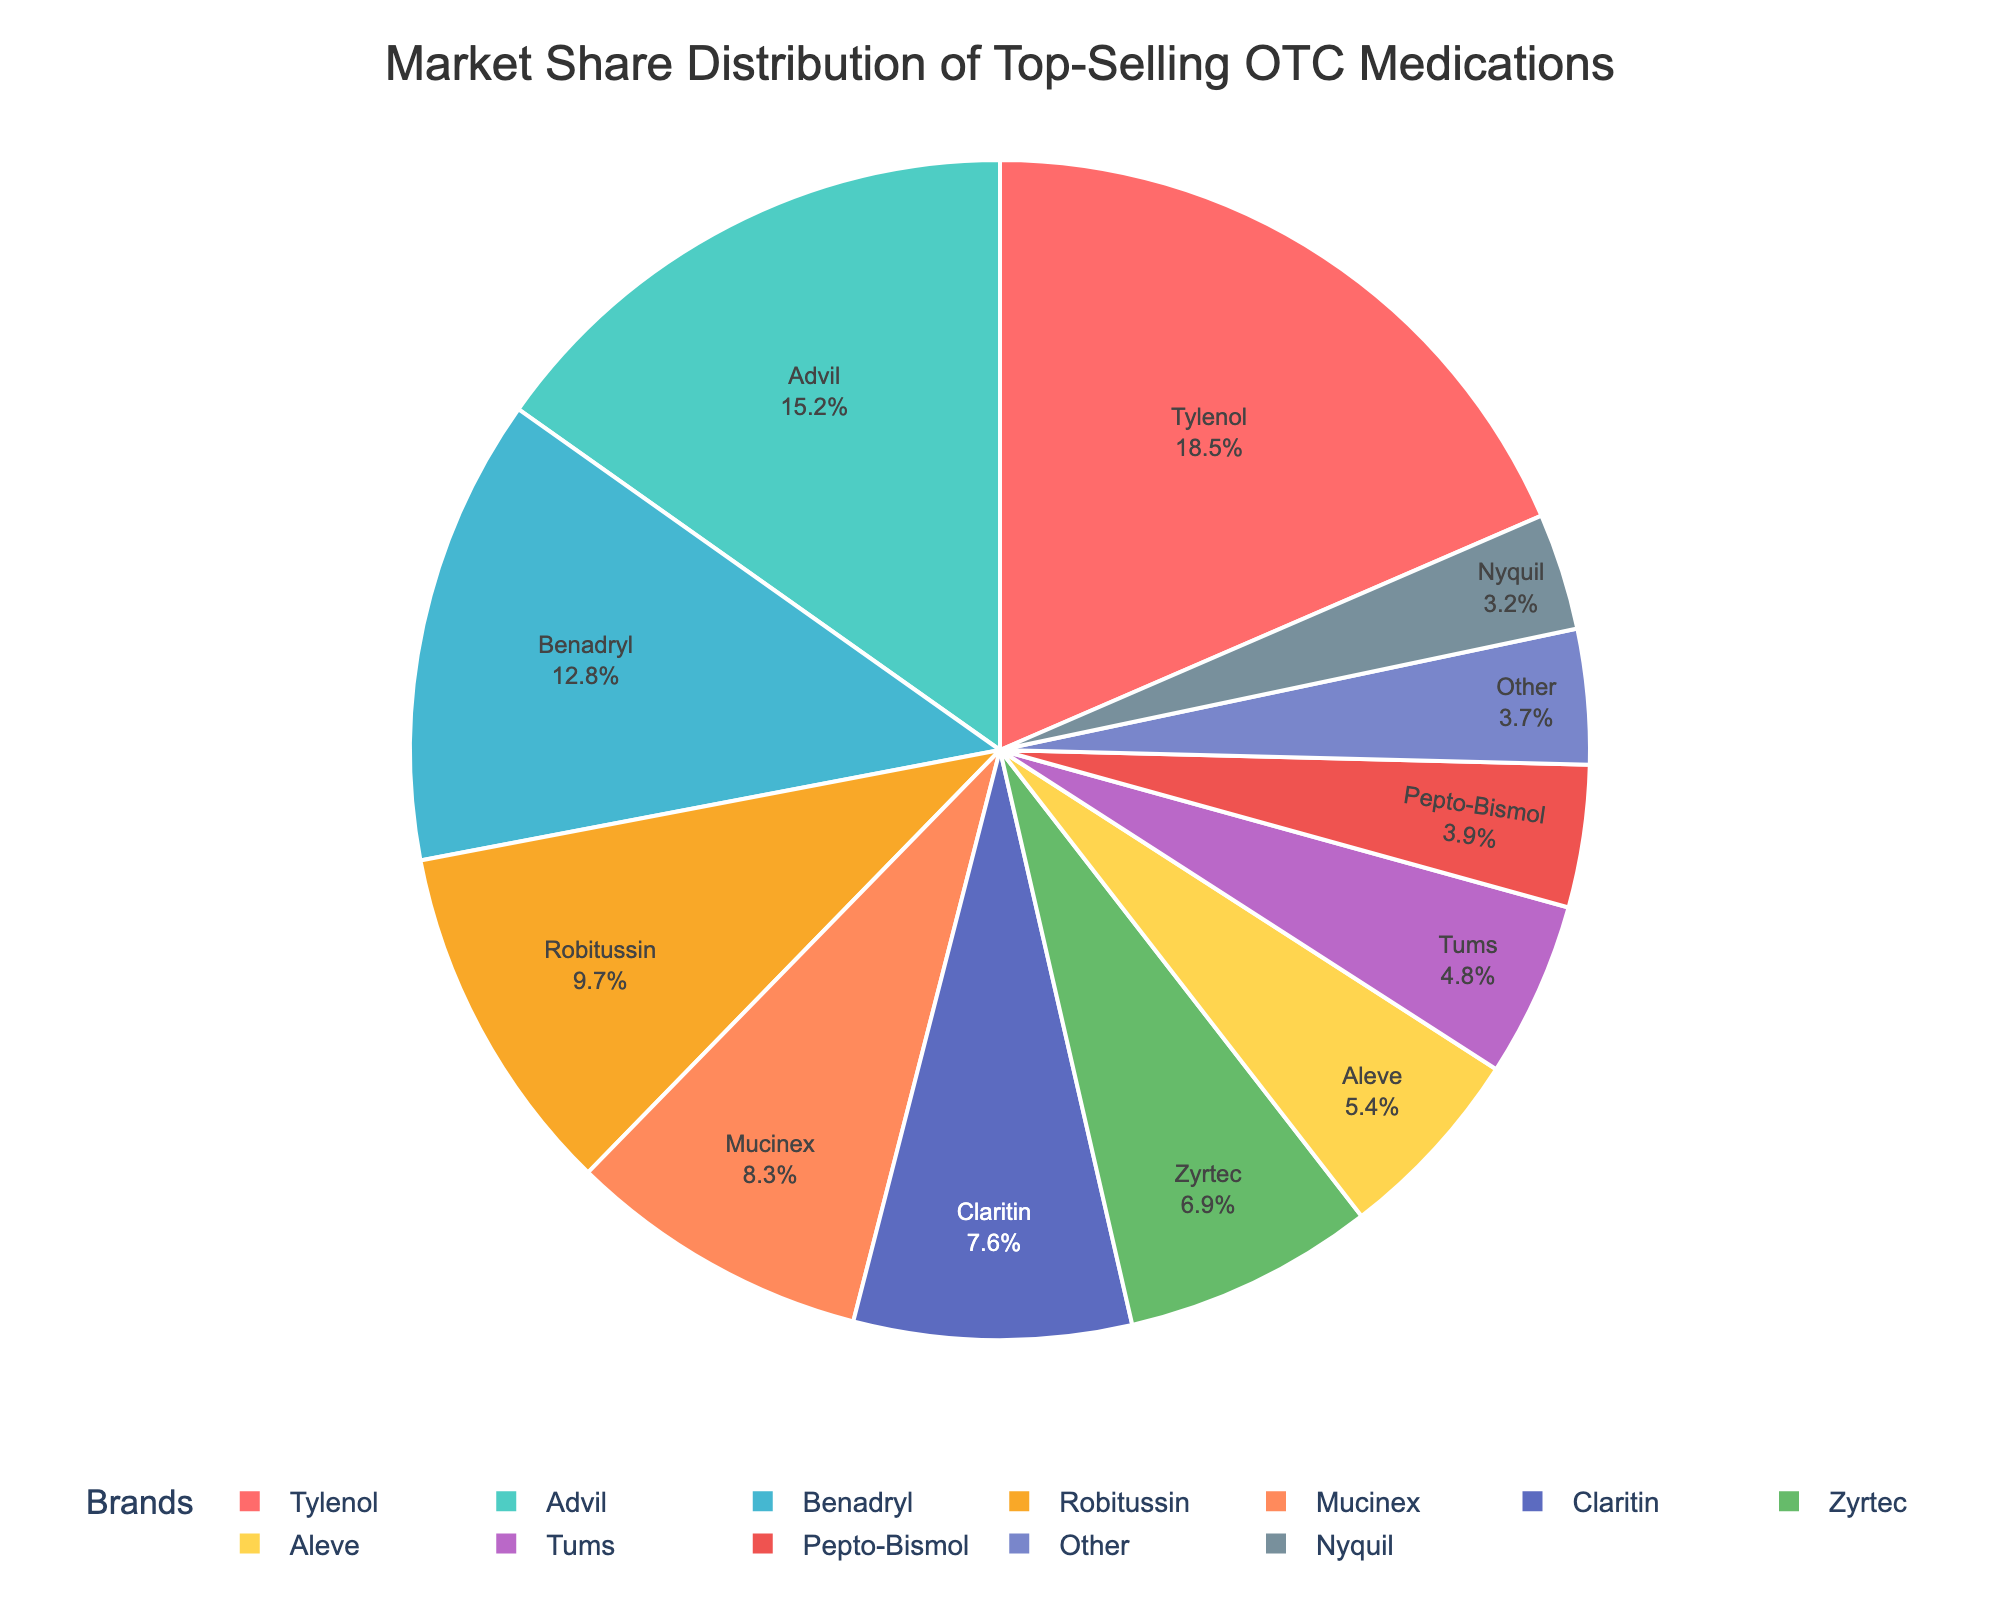What is the market share of the brand with the highest percentage? The brand with the highest market share (Tylenol) can be identified by observing the pie chart where the section is largest or highest and noted with 18.5%.
Answer: 18.5% Which brand has a larger market share, Advil or Benadryl? Comparing the market shares, Advil has 15.2% and Benadryl has 12.8%. Advil's slice is larger than Benadryl’s slice, thus Advil has a larger market share.
Answer: Advil What is the combined market share of Robitussin, Claritin, and Nyquil? Add the market shares: Robitussin (9.7%) + Claritin (7.6%) + Nyquil (3.2%) = 20.5%.
Answer: 20.5% Which brand has nearly similar market share as Tums? Tums has a market share of 4.8%. By examining the nearby values, Pepto-Bismol with 3.9% is the closest.
Answer: Pepto-Bismol What is the visual color used for Zyrtec on the pie chart? By observing the pie chart, Zyrtec is identified by the sixth slice colored in green.
Answer: Green How does the market share of Aleve compare to that of Mucinex? Aleve has a market share of 5.4% while Mucinex has 8.3%. By comparison, Aleve’s slice is smaller than Mucinex's slice, hence Mucinex has a larger market share.
Answer: Mucinex What percentage of the market do the three brands with the smallest shares hold? The three smallest shares are Nyquil (3.2%), Pepto-Bismol (3.9%), Other (3.7%). Adding them: 3.2% + 3.9% + 3.7% = 10.8%.
Answer: 10.8% Is the market share of Benadryl more than twice that of Nyquil? Benadryl has a market share of 12.8% and Nyquil has 3.2%. Checking the ratio, 12.8% / 3.2% = 4, which shows Benadryl's market share is more than twice Nyquil’s.
Answer: Yes 